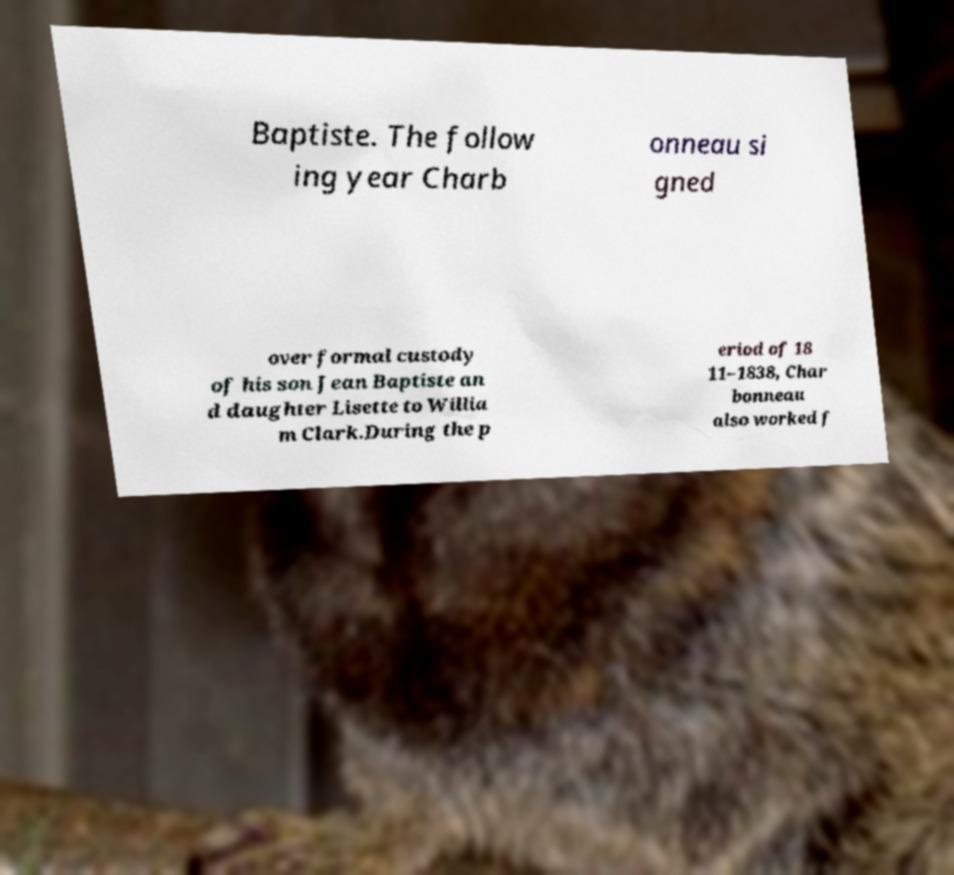What messages or text are displayed in this image? I need them in a readable, typed format. Baptiste. The follow ing year Charb onneau si gned over formal custody of his son Jean Baptiste an d daughter Lisette to Willia m Clark.During the p eriod of 18 11–1838, Char bonneau also worked f 